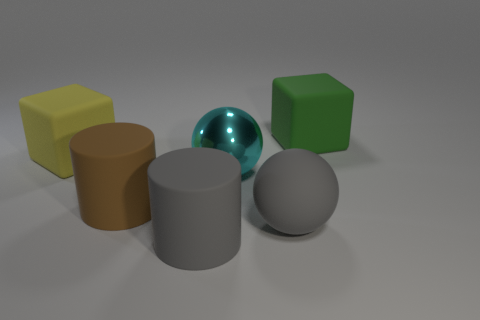The other big matte thing that is the same shape as the yellow object is what color? green 